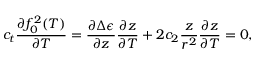<formula> <loc_0><loc_0><loc_500><loc_500>c _ { t } \frac { \partial f _ { 0 } ^ { 2 } ( T ) } { \partial T } = \frac { \partial \Delta \epsilon } { \partial z } \frac { \partial z } { \partial T } + 2 c _ { 2 } \frac { z } { r ^ { 2 } } \frac { \partial z } { \partial T } = 0 ,</formula> 